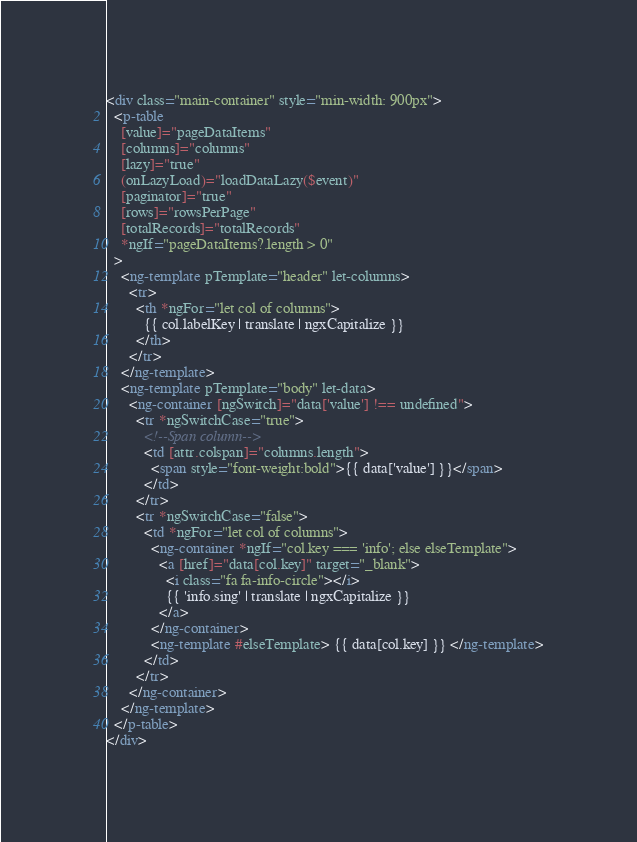<code> <loc_0><loc_0><loc_500><loc_500><_HTML_><div class="main-container" style="min-width: 900px">
  <p-table
    [value]="pageDataItems"
    [columns]="columns"
    [lazy]="true"
    (onLazyLoad)="loadDataLazy($event)"
    [paginator]="true"
    [rows]="rowsPerPage"
    [totalRecords]="totalRecords"
    *ngIf="pageDataItems?.length > 0"
  >
    <ng-template pTemplate="header" let-columns>
      <tr>
        <th *ngFor="let col of columns">
          {{ col.labelKey | translate | ngxCapitalize }}
        </th>
      </tr>
    </ng-template>
    <ng-template pTemplate="body" let-data>
      <ng-container [ngSwitch]="data['value'] !== undefined">
        <tr *ngSwitchCase="true">
          <!--Span column-->
          <td [attr.colspan]="columns.length">
            <span style="font-weight:bold">{{ data['value'] }}</span>
          </td>
        </tr>
        <tr *ngSwitchCase="false">
          <td *ngFor="let col of columns">
            <ng-container *ngIf="col.key === 'info'; else elseTemplate">
              <a [href]="data[col.key]" target="_blank">
                <i class="fa fa-info-circle"></i>
                {{ 'info.sing' | translate | ngxCapitalize }}
              </a>
            </ng-container>
            <ng-template #elseTemplate> {{ data[col.key] }} </ng-template>
          </td>
        </tr>
      </ng-container>
    </ng-template>
  </p-table>
</div>
</code> 